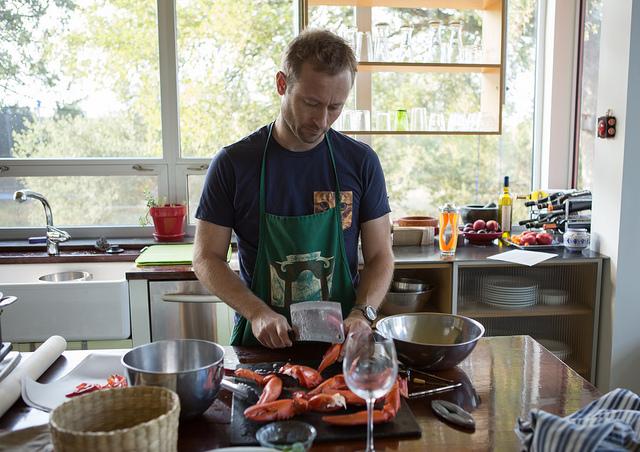What color is the apron?
Give a very brief answer. Green. Which room is this?
Give a very brief answer. Kitchen. Is the man cooking?
Give a very brief answer. Yes. 